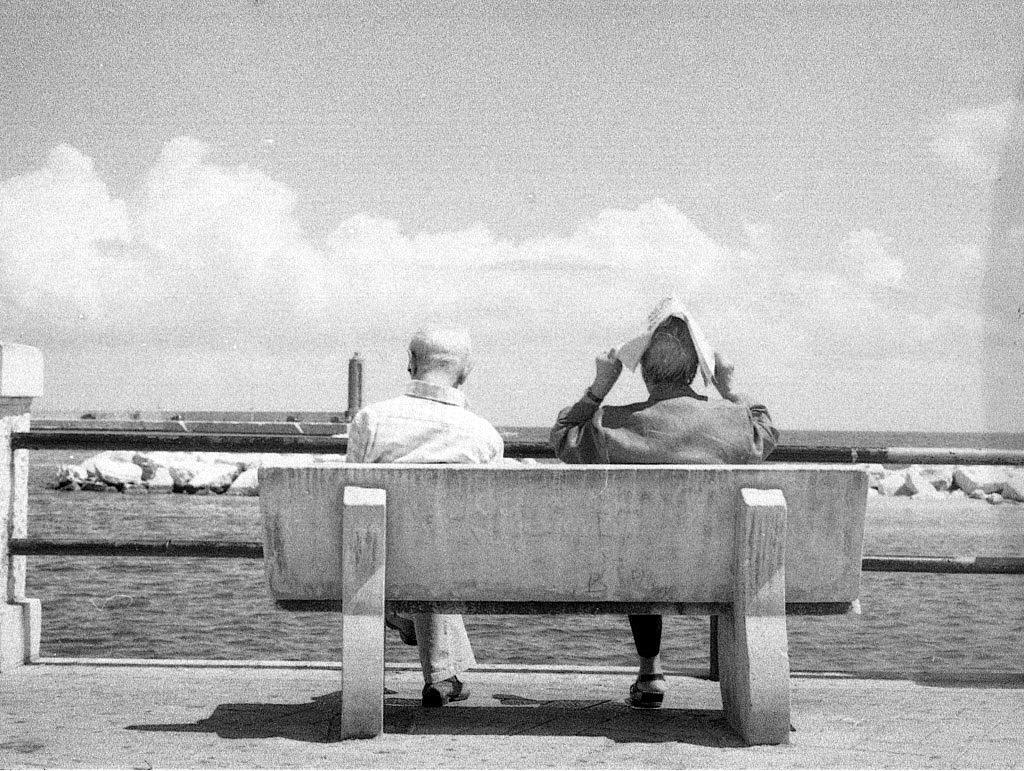Can you describe this image briefly? In this image in the center there are two persons who are sitting on chair. On the background there is sky, and in the bottom there is a river and some stones are there. 